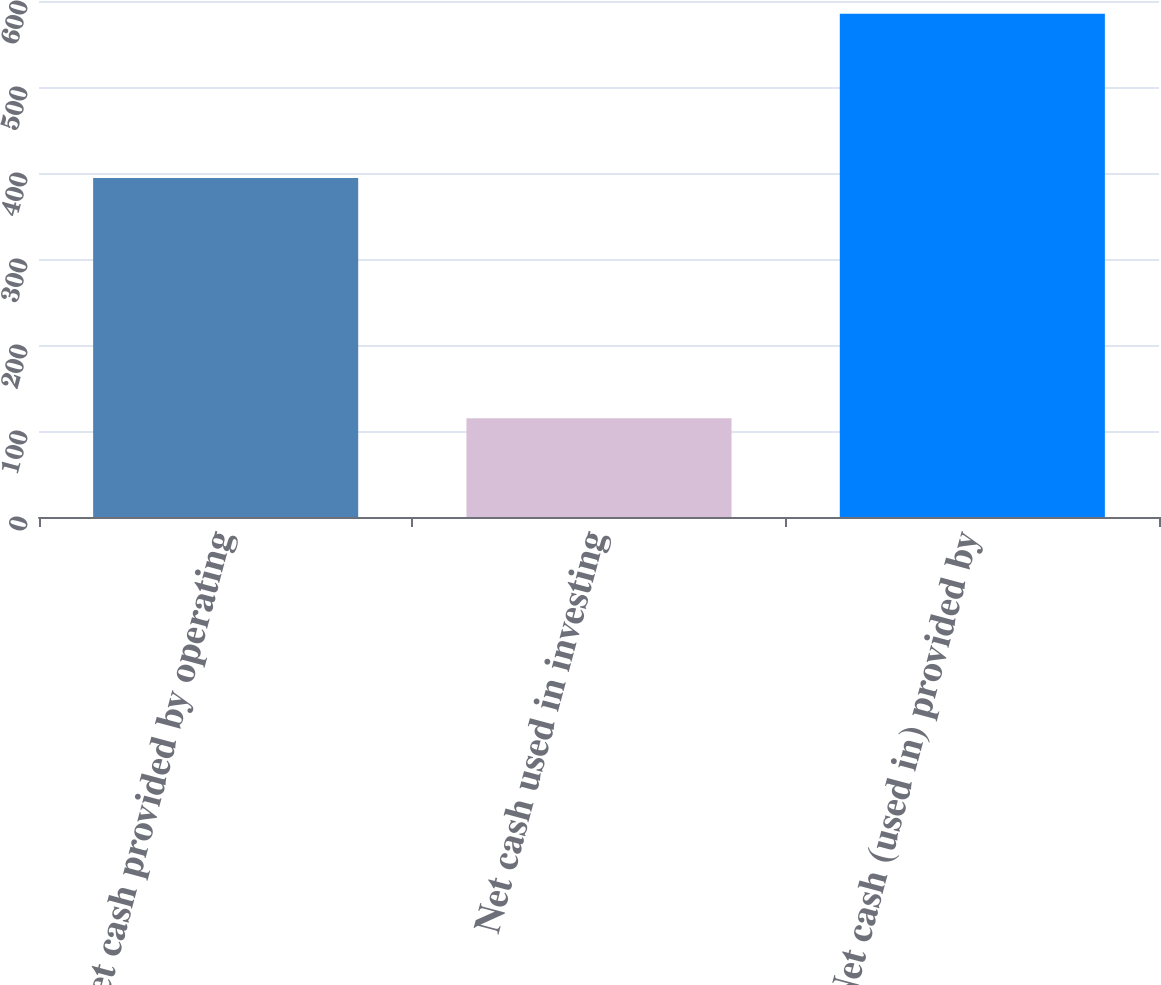Convert chart to OTSL. <chart><loc_0><loc_0><loc_500><loc_500><bar_chart><fcel>Net cash provided by operating<fcel>Net cash used in investing<fcel>Net cash (used in) provided by<nl><fcel>394.2<fcel>114.9<fcel>585.1<nl></chart> 